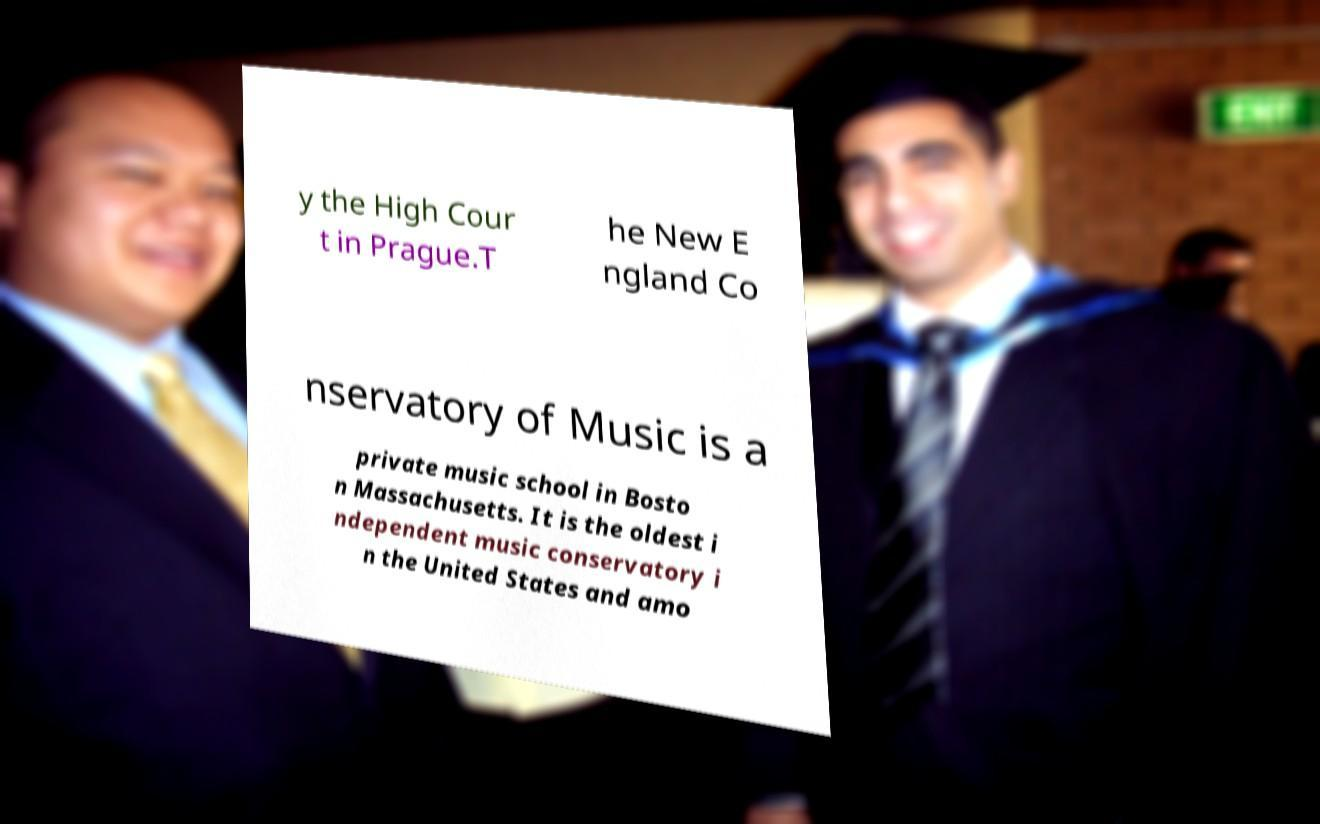There's text embedded in this image that I need extracted. Can you transcribe it verbatim? y the High Cour t in Prague.T he New E ngland Co nservatory of Music is a private music school in Bosto n Massachusetts. It is the oldest i ndependent music conservatory i n the United States and amo 